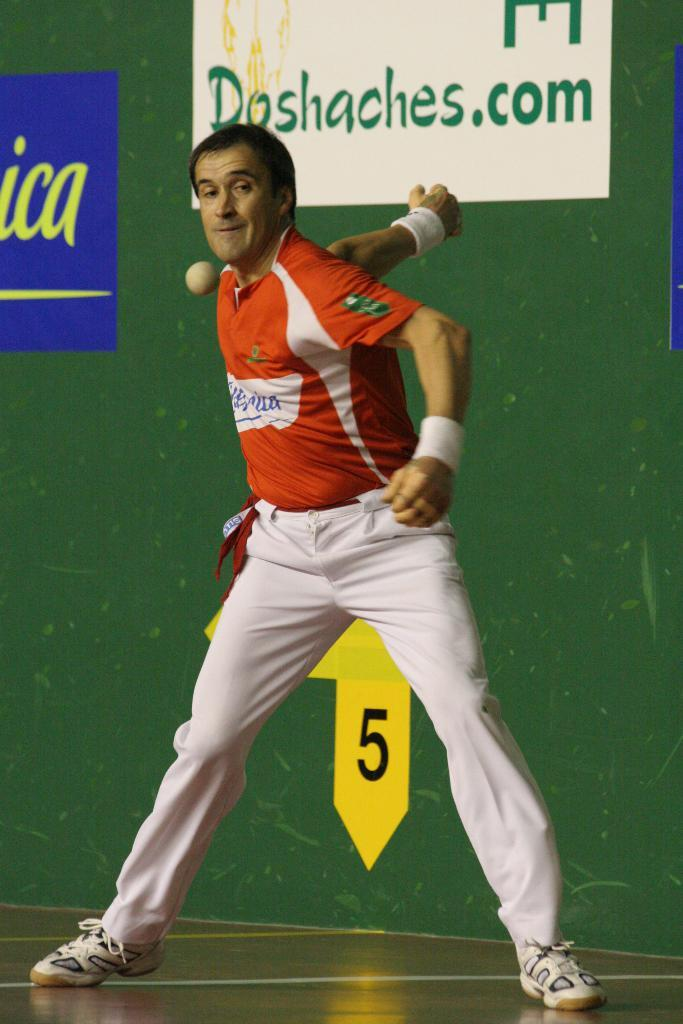<image>
Provide a brief description of the given image. a man is standing in front of the number 5 